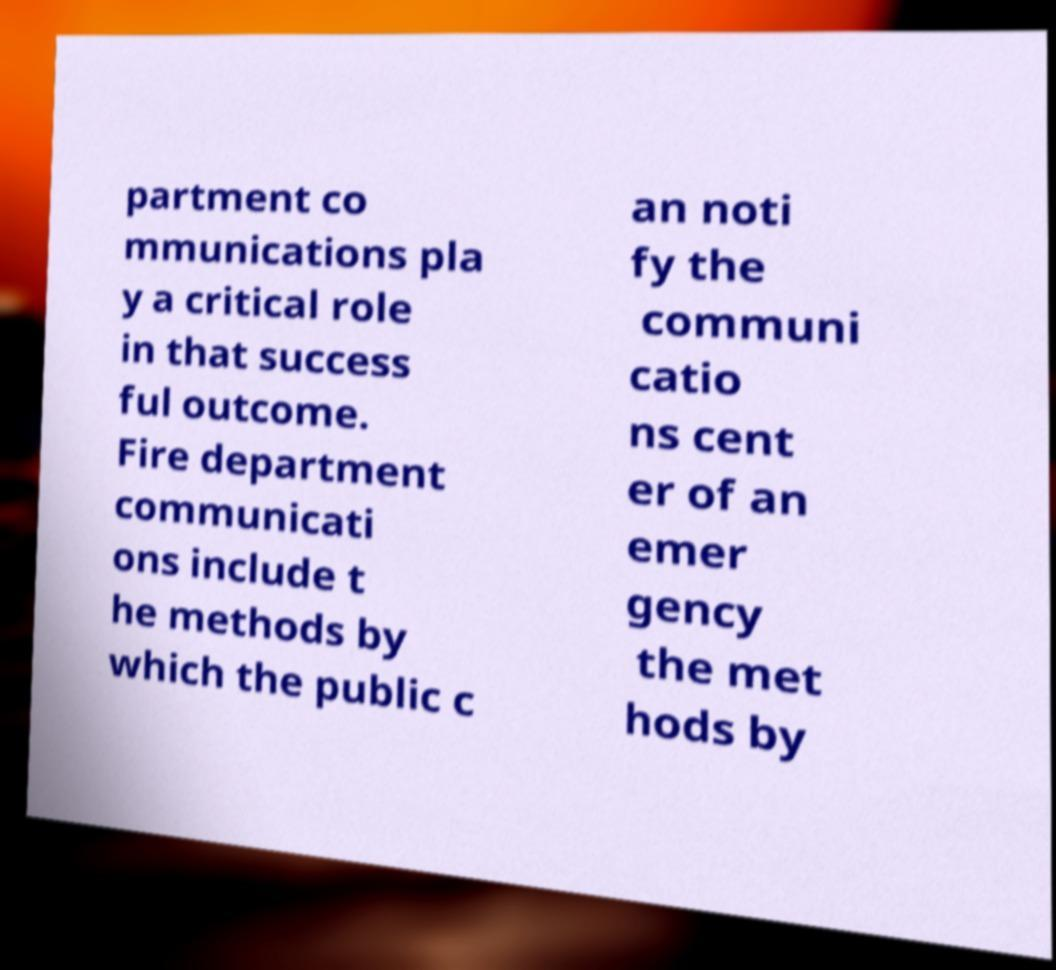Can you accurately transcribe the text from the provided image for me? partment co mmunications pla y a critical role in that success ful outcome. Fire department communicati ons include t he methods by which the public c an noti fy the communi catio ns cent er of an emer gency the met hods by 